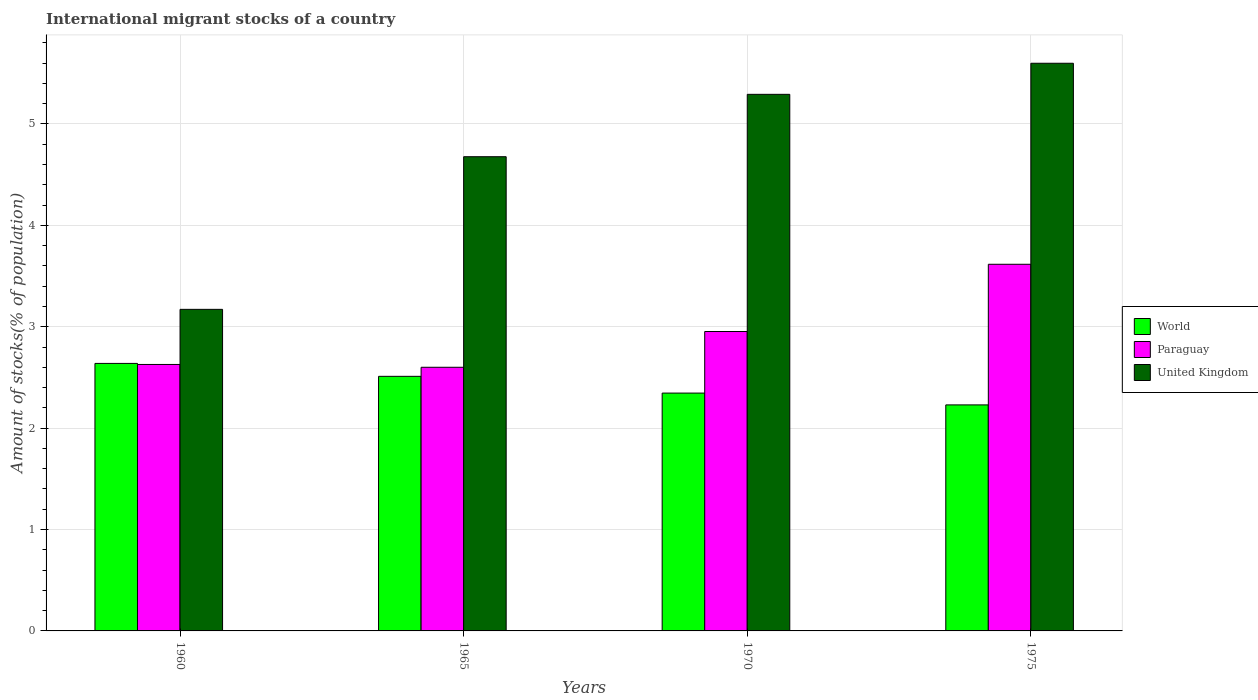How many different coloured bars are there?
Give a very brief answer. 3. How many groups of bars are there?
Your answer should be very brief. 4. How many bars are there on the 3rd tick from the left?
Make the answer very short. 3. What is the label of the 1st group of bars from the left?
Your response must be concise. 1960. In how many cases, is the number of bars for a given year not equal to the number of legend labels?
Make the answer very short. 0. What is the amount of stocks in in United Kingdom in 1965?
Make the answer very short. 4.68. Across all years, what is the maximum amount of stocks in in United Kingdom?
Ensure brevity in your answer.  5.6. Across all years, what is the minimum amount of stocks in in World?
Keep it short and to the point. 2.23. What is the total amount of stocks in in Paraguay in the graph?
Your answer should be compact. 11.8. What is the difference between the amount of stocks in in United Kingdom in 1960 and that in 1970?
Make the answer very short. -2.12. What is the difference between the amount of stocks in in United Kingdom in 1975 and the amount of stocks in in Paraguay in 1960?
Provide a short and direct response. 2.97. What is the average amount of stocks in in United Kingdom per year?
Give a very brief answer. 4.68. In the year 1960, what is the difference between the amount of stocks in in United Kingdom and amount of stocks in in World?
Make the answer very short. 0.53. In how many years, is the amount of stocks in in World greater than 2.6 %?
Offer a very short reply. 1. What is the ratio of the amount of stocks in in United Kingdom in 1970 to that in 1975?
Your answer should be very brief. 0.95. Is the amount of stocks in in United Kingdom in 1965 less than that in 1970?
Offer a very short reply. Yes. Is the difference between the amount of stocks in in United Kingdom in 1965 and 1970 greater than the difference between the amount of stocks in in World in 1965 and 1970?
Your answer should be compact. No. What is the difference between the highest and the second highest amount of stocks in in World?
Provide a short and direct response. 0.13. What is the difference between the highest and the lowest amount of stocks in in Paraguay?
Offer a terse response. 1.02. In how many years, is the amount of stocks in in World greater than the average amount of stocks in in World taken over all years?
Keep it short and to the point. 2. What does the 3rd bar from the left in 1960 represents?
Make the answer very short. United Kingdom. Is it the case that in every year, the sum of the amount of stocks in in United Kingdom and amount of stocks in in Paraguay is greater than the amount of stocks in in World?
Keep it short and to the point. Yes. How many bars are there?
Your answer should be very brief. 12. How many years are there in the graph?
Make the answer very short. 4. Are the values on the major ticks of Y-axis written in scientific E-notation?
Ensure brevity in your answer.  No. Does the graph contain grids?
Make the answer very short. Yes. Where does the legend appear in the graph?
Your response must be concise. Center right. How many legend labels are there?
Offer a terse response. 3. What is the title of the graph?
Ensure brevity in your answer.  International migrant stocks of a country. Does "Liberia" appear as one of the legend labels in the graph?
Give a very brief answer. No. What is the label or title of the Y-axis?
Provide a succinct answer. Amount of stocks(% of population). What is the Amount of stocks(% of population) in World in 1960?
Your answer should be compact. 2.64. What is the Amount of stocks(% of population) in Paraguay in 1960?
Provide a succinct answer. 2.63. What is the Amount of stocks(% of population) of United Kingdom in 1960?
Ensure brevity in your answer.  3.17. What is the Amount of stocks(% of population) in World in 1965?
Give a very brief answer. 2.51. What is the Amount of stocks(% of population) in Paraguay in 1965?
Give a very brief answer. 2.6. What is the Amount of stocks(% of population) of United Kingdom in 1965?
Provide a succinct answer. 4.68. What is the Amount of stocks(% of population) in World in 1970?
Your answer should be very brief. 2.35. What is the Amount of stocks(% of population) in Paraguay in 1970?
Your answer should be compact. 2.95. What is the Amount of stocks(% of population) in United Kingdom in 1970?
Your answer should be compact. 5.29. What is the Amount of stocks(% of population) of World in 1975?
Provide a succinct answer. 2.23. What is the Amount of stocks(% of population) of Paraguay in 1975?
Offer a very short reply. 3.62. What is the Amount of stocks(% of population) of United Kingdom in 1975?
Your response must be concise. 5.6. Across all years, what is the maximum Amount of stocks(% of population) in World?
Your answer should be compact. 2.64. Across all years, what is the maximum Amount of stocks(% of population) of Paraguay?
Make the answer very short. 3.62. Across all years, what is the maximum Amount of stocks(% of population) of United Kingdom?
Offer a very short reply. 5.6. Across all years, what is the minimum Amount of stocks(% of population) of World?
Your answer should be very brief. 2.23. Across all years, what is the minimum Amount of stocks(% of population) in Paraguay?
Your answer should be very brief. 2.6. Across all years, what is the minimum Amount of stocks(% of population) in United Kingdom?
Offer a terse response. 3.17. What is the total Amount of stocks(% of population) of World in the graph?
Give a very brief answer. 9.72. What is the total Amount of stocks(% of population) in Paraguay in the graph?
Provide a succinct answer. 11.8. What is the total Amount of stocks(% of population) of United Kingdom in the graph?
Offer a terse response. 18.74. What is the difference between the Amount of stocks(% of population) in World in 1960 and that in 1965?
Keep it short and to the point. 0.13. What is the difference between the Amount of stocks(% of population) of Paraguay in 1960 and that in 1965?
Ensure brevity in your answer.  0.03. What is the difference between the Amount of stocks(% of population) in United Kingdom in 1960 and that in 1965?
Your answer should be compact. -1.51. What is the difference between the Amount of stocks(% of population) of World in 1960 and that in 1970?
Provide a short and direct response. 0.29. What is the difference between the Amount of stocks(% of population) in Paraguay in 1960 and that in 1970?
Offer a very short reply. -0.32. What is the difference between the Amount of stocks(% of population) in United Kingdom in 1960 and that in 1970?
Your answer should be compact. -2.12. What is the difference between the Amount of stocks(% of population) of World in 1960 and that in 1975?
Offer a terse response. 0.41. What is the difference between the Amount of stocks(% of population) in Paraguay in 1960 and that in 1975?
Give a very brief answer. -0.99. What is the difference between the Amount of stocks(% of population) of United Kingdom in 1960 and that in 1975?
Your answer should be very brief. -2.43. What is the difference between the Amount of stocks(% of population) in World in 1965 and that in 1970?
Provide a succinct answer. 0.17. What is the difference between the Amount of stocks(% of population) in Paraguay in 1965 and that in 1970?
Your answer should be compact. -0.35. What is the difference between the Amount of stocks(% of population) of United Kingdom in 1965 and that in 1970?
Provide a short and direct response. -0.62. What is the difference between the Amount of stocks(% of population) in World in 1965 and that in 1975?
Your answer should be compact. 0.28. What is the difference between the Amount of stocks(% of population) of Paraguay in 1965 and that in 1975?
Provide a short and direct response. -1.02. What is the difference between the Amount of stocks(% of population) of United Kingdom in 1965 and that in 1975?
Offer a terse response. -0.92. What is the difference between the Amount of stocks(% of population) of World in 1970 and that in 1975?
Ensure brevity in your answer.  0.12. What is the difference between the Amount of stocks(% of population) of Paraguay in 1970 and that in 1975?
Make the answer very short. -0.66. What is the difference between the Amount of stocks(% of population) of United Kingdom in 1970 and that in 1975?
Your response must be concise. -0.31. What is the difference between the Amount of stocks(% of population) of World in 1960 and the Amount of stocks(% of population) of Paraguay in 1965?
Your response must be concise. 0.04. What is the difference between the Amount of stocks(% of population) in World in 1960 and the Amount of stocks(% of population) in United Kingdom in 1965?
Offer a terse response. -2.04. What is the difference between the Amount of stocks(% of population) of Paraguay in 1960 and the Amount of stocks(% of population) of United Kingdom in 1965?
Your answer should be compact. -2.05. What is the difference between the Amount of stocks(% of population) of World in 1960 and the Amount of stocks(% of population) of Paraguay in 1970?
Ensure brevity in your answer.  -0.31. What is the difference between the Amount of stocks(% of population) of World in 1960 and the Amount of stocks(% of population) of United Kingdom in 1970?
Offer a terse response. -2.65. What is the difference between the Amount of stocks(% of population) in Paraguay in 1960 and the Amount of stocks(% of population) in United Kingdom in 1970?
Give a very brief answer. -2.66. What is the difference between the Amount of stocks(% of population) in World in 1960 and the Amount of stocks(% of population) in Paraguay in 1975?
Give a very brief answer. -0.98. What is the difference between the Amount of stocks(% of population) in World in 1960 and the Amount of stocks(% of population) in United Kingdom in 1975?
Your answer should be very brief. -2.96. What is the difference between the Amount of stocks(% of population) of Paraguay in 1960 and the Amount of stocks(% of population) of United Kingdom in 1975?
Provide a short and direct response. -2.97. What is the difference between the Amount of stocks(% of population) of World in 1965 and the Amount of stocks(% of population) of Paraguay in 1970?
Your answer should be compact. -0.44. What is the difference between the Amount of stocks(% of population) in World in 1965 and the Amount of stocks(% of population) in United Kingdom in 1970?
Offer a terse response. -2.78. What is the difference between the Amount of stocks(% of population) of Paraguay in 1965 and the Amount of stocks(% of population) of United Kingdom in 1970?
Offer a terse response. -2.69. What is the difference between the Amount of stocks(% of population) of World in 1965 and the Amount of stocks(% of population) of Paraguay in 1975?
Provide a short and direct response. -1.11. What is the difference between the Amount of stocks(% of population) of World in 1965 and the Amount of stocks(% of population) of United Kingdom in 1975?
Provide a succinct answer. -3.09. What is the difference between the Amount of stocks(% of population) in Paraguay in 1965 and the Amount of stocks(% of population) in United Kingdom in 1975?
Give a very brief answer. -3. What is the difference between the Amount of stocks(% of population) of World in 1970 and the Amount of stocks(% of population) of Paraguay in 1975?
Your response must be concise. -1.27. What is the difference between the Amount of stocks(% of population) in World in 1970 and the Amount of stocks(% of population) in United Kingdom in 1975?
Provide a succinct answer. -3.25. What is the difference between the Amount of stocks(% of population) of Paraguay in 1970 and the Amount of stocks(% of population) of United Kingdom in 1975?
Keep it short and to the point. -2.65. What is the average Amount of stocks(% of population) of World per year?
Provide a short and direct response. 2.43. What is the average Amount of stocks(% of population) of Paraguay per year?
Ensure brevity in your answer.  2.95. What is the average Amount of stocks(% of population) in United Kingdom per year?
Offer a very short reply. 4.68. In the year 1960, what is the difference between the Amount of stocks(% of population) of World and Amount of stocks(% of population) of Paraguay?
Give a very brief answer. 0.01. In the year 1960, what is the difference between the Amount of stocks(% of population) of World and Amount of stocks(% of population) of United Kingdom?
Your answer should be compact. -0.53. In the year 1960, what is the difference between the Amount of stocks(% of population) in Paraguay and Amount of stocks(% of population) in United Kingdom?
Your response must be concise. -0.54. In the year 1965, what is the difference between the Amount of stocks(% of population) of World and Amount of stocks(% of population) of Paraguay?
Keep it short and to the point. -0.09. In the year 1965, what is the difference between the Amount of stocks(% of population) in World and Amount of stocks(% of population) in United Kingdom?
Offer a very short reply. -2.17. In the year 1965, what is the difference between the Amount of stocks(% of population) in Paraguay and Amount of stocks(% of population) in United Kingdom?
Give a very brief answer. -2.08. In the year 1970, what is the difference between the Amount of stocks(% of population) of World and Amount of stocks(% of population) of Paraguay?
Offer a terse response. -0.61. In the year 1970, what is the difference between the Amount of stocks(% of population) in World and Amount of stocks(% of population) in United Kingdom?
Give a very brief answer. -2.95. In the year 1970, what is the difference between the Amount of stocks(% of population) in Paraguay and Amount of stocks(% of population) in United Kingdom?
Provide a short and direct response. -2.34. In the year 1975, what is the difference between the Amount of stocks(% of population) in World and Amount of stocks(% of population) in Paraguay?
Offer a terse response. -1.39. In the year 1975, what is the difference between the Amount of stocks(% of population) of World and Amount of stocks(% of population) of United Kingdom?
Keep it short and to the point. -3.37. In the year 1975, what is the difference between the Amount of stocks(% of population) of Paraguay and Amount of stocks(% of population) of United Kingdom?
Your answer should be very brief. -1.98. What is the ratio of the Amount of stocks(% of population) of World in 1960 to that in 1965?
Keep it short and to the point. 1.05. What is the ratio of the Amount of stocks(% of population) in Paraguay in 1960 to that in 1965?
Offer a terse response. 1.01. What is the ratio of the Amount of stocks(% of population) in United Kingdom in 1960 to that in 1965?
Ensure brevity in your answer.  0.68. What is the ratio of the Amount of stocks(% of population) of World in 1960 to that in 1970?
Keep it short and to the point. 1.12. What is the ratio of the Amount of stocks(% of population) of Paraguay in 1960 to that in 1970?
Offer a very short reply. 0.89. What is the ratio of the Amount of stocks(% of population) of United Kingdom in 1960 to that in 1970?
Your answer should be very brief. 0.6. What is the ratio of the Amount of stocks(% of population) of World in 1960 to that in 1975?
Offer a very short reply. 1.18. What is the ratio of the Amount of stocks(% of population) of Paraguay in 1960 to that in 1975?
Ensure brevity in your answer.  0.73. What is the ratio of the Amount of stocks(% of population) of United Kingdom in 1960 to that in 1975?
Provide a short and direct response. 0.57. What is the ratio of the Amount of stocks(% of population) of World in 1965 to that in 1970?
Ensure brevity in your answer.  1.07. What is the ratio of the Amount of stocks(% of population) in Paraguay in 1965 to that in 1970?
Provide a short and direct response. 0.88. What is the ratio of the Amount of stocks(% of population) in United Kingdom in 1965 to that in 1970?
Offer a very short reply. 0.88. What is the ratio of the Amount of stocks(% of population) in World in 1965 to that in 1975?
Provide a succinct answer. 1.13. What is the ratio of the Amount of stocks(% of population) in Paraguay in 1965 to that in 1975?
Provide a short and direct response. 0.72. What is the ratio of the Amount of stocks(% of population) in United Kingdom in 1965 to that in 1975?
Your response must be concise. 0.84. What is the ratio of the Amount of stocks(% of population) of World in 1970 to that in 1975?
Provide a succinct answer. 1.05. What is the ratio of the Amount of stocks(% of population) in Paraguay in 1970 to that in 1975?
Provide a succinct answer. 0.82. What is the ratio of the Amount of stocks(% of population) in United Kingdom in 1970 to that in 1975?
Your answer should be compact. 0.95. What is the difference between the highest and the second highest Amount of stocks(% of population) in World?
Ensure brevity in your answer.  0.13. What is the difference between the highest and the second highest Amount of stocks(% of population) of Paraguay?
Give a very brief answer. 0.66. What is the difference between the highest and the second highest Amount of stocks(% of population) of United Kingdom?
Offer a very short reply. 0.31. What is the difference between the highest and the lowest Amount of stocks(% of population) of World?
Your answer should be compact. 0.41. What is the difference between the highest and the lowest Amount of stocks(% of population) in Paraguay?
Keep it short and to the point. 1.02. What is the difference between the highest and the lowest Amount of stocks(% of population) in United Kingdom?
Make the answer very short. 2.43. 